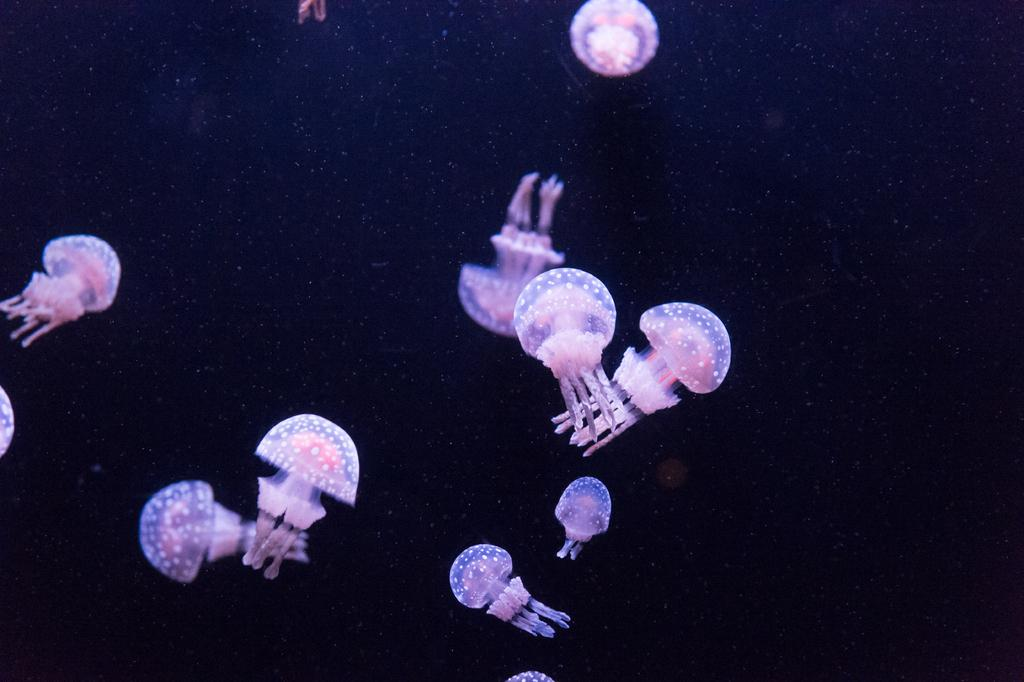What type of marine animals are in the image? There are jellyfishes in the image. What is the color of the background in the image? The background of the image is dark. Can you see a match being lit in the image? There is no match present in the image. What type of lipstick is the person wearing in the image? There is no person or lipstick present in the image. 